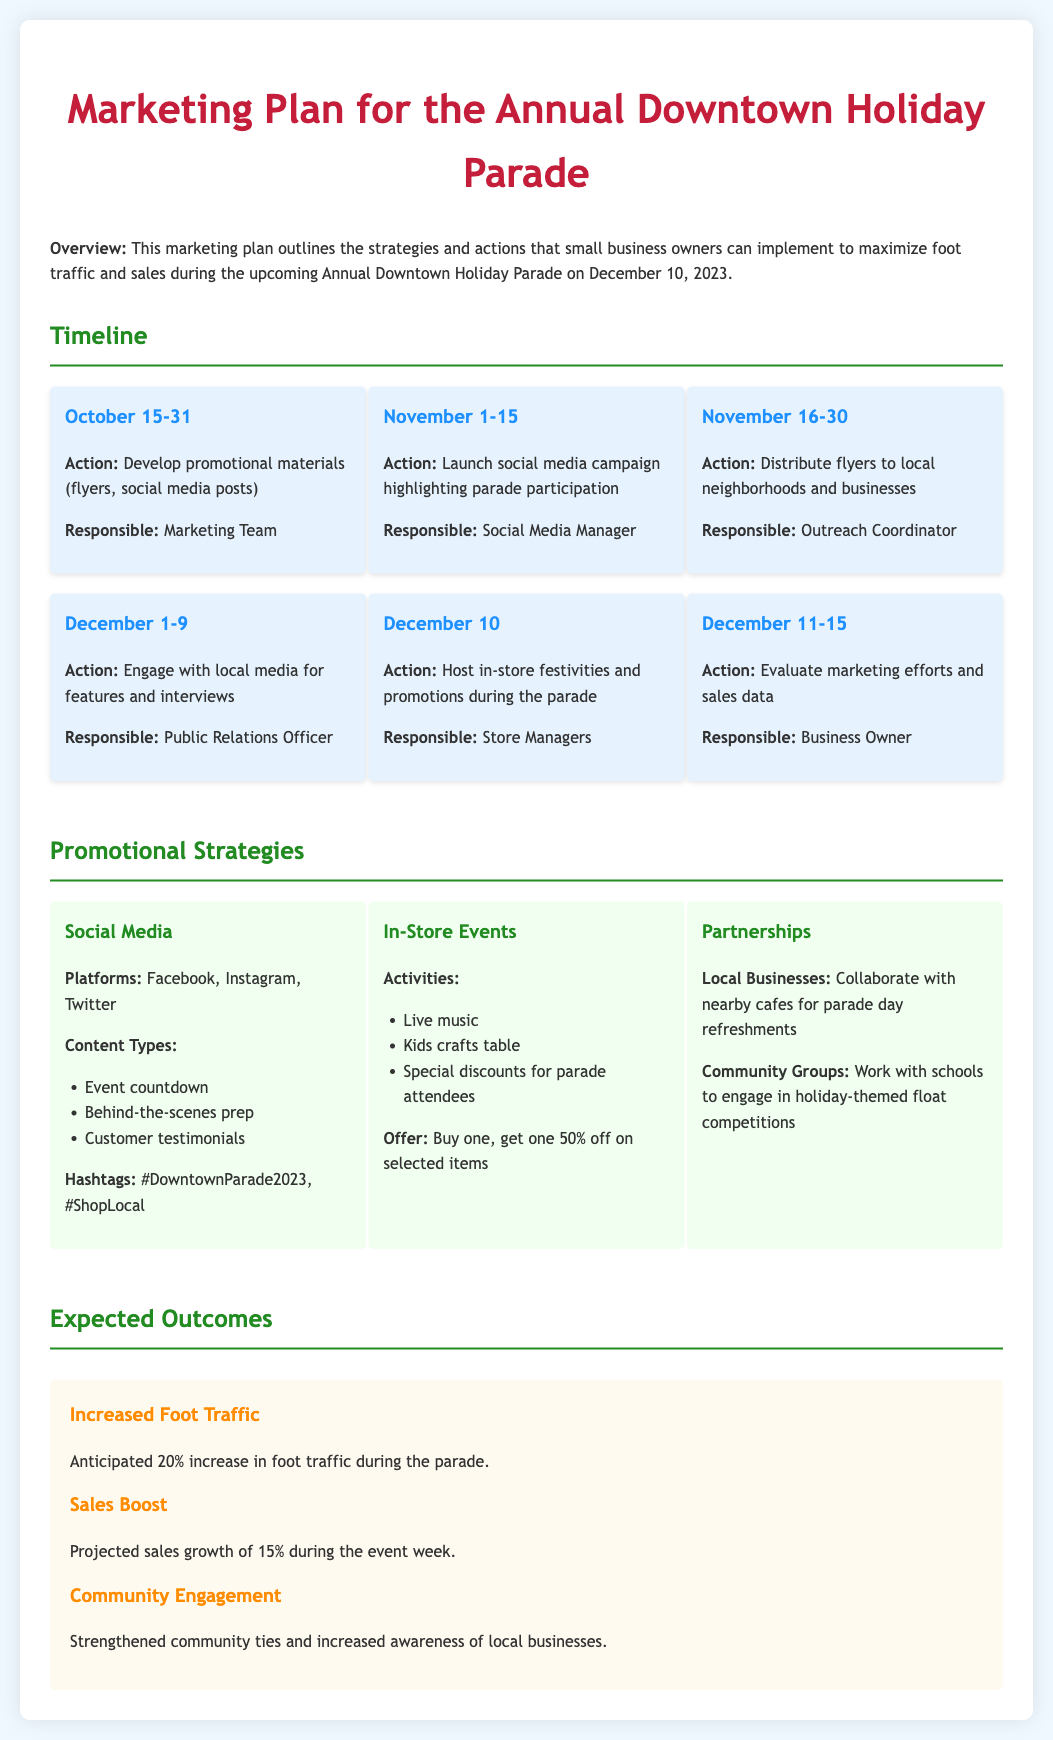What is the event date? The event date is specifically mentioned in the document as December 10, 2023.
Answer: December 10, 2023 Who is responsible for developing promotional materials? The responsible party for developing promotional materials is identified as the Marketing Team.
Answer: Marketing Team What is the expected increase in foot traffic during the parade? The document states that there is an anticipated 20% increase in foot traffic during the parade.
Answer: 20% What promotional strategy involves local businesses? The strategy that involves local businesses is referred to as Partnerships.
Answer: Partnerships When should flyers be distributed? The designated period for distributing flyers is from November 16 to November 30.
Answer: November 16-30 What discount is offered for parade attendees? The document lists that the offer is buy one, get one 50% off on selected items for parade attendees.
Answer: Buy one, get one 50% off Who evaluates marketing efforts and sales data? The evaluation of marketing efforts and sales data is the responsibility of the Business Owner.
Answer: Business Owner What is the content type for social media promotions? The content types for social media promotions include behind-the-scenes prep, among others.
Answer: Behind-the-scenes prep What are the activities planned for in-store events? The activities planned for in-store events include live music, kids crafts table, and more.
Answer: Live music 